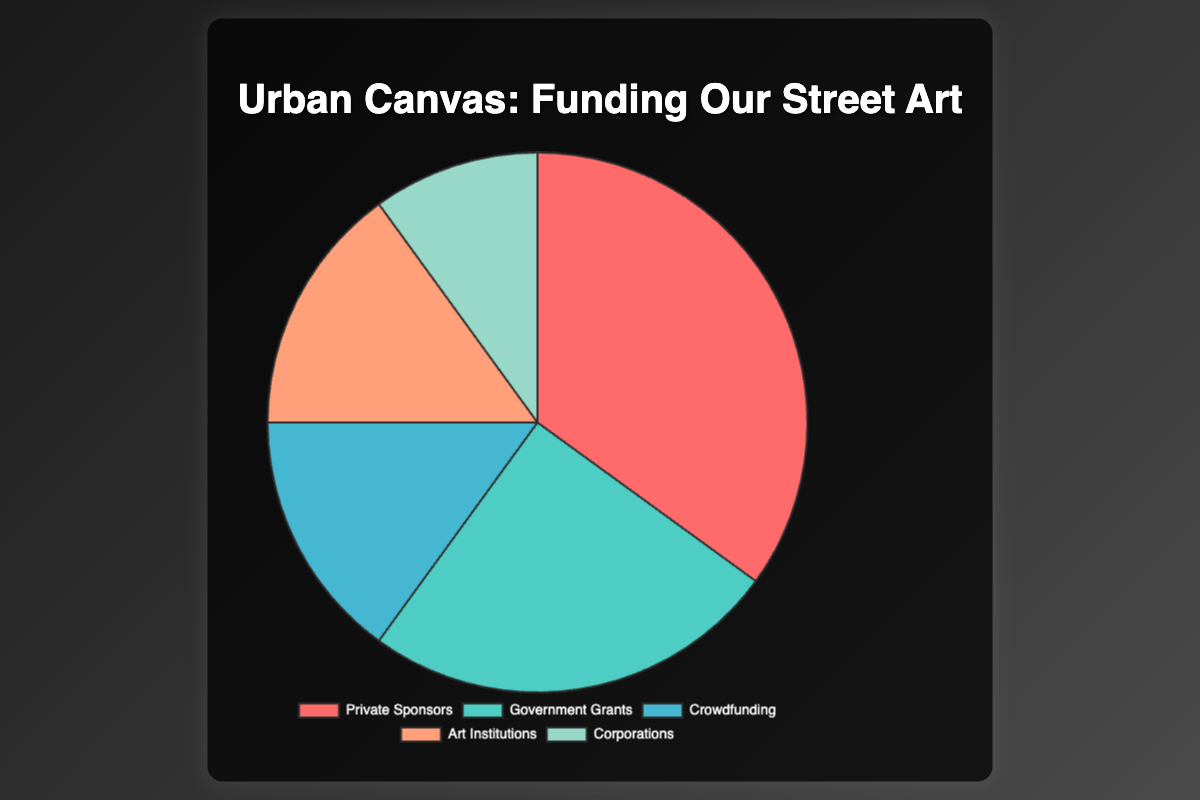What is the largest source of funding for street art projects? The figure shows the share of each funding source in the form of a pie chart. The segment with the highest percentage represents the largest source of funding. In this chart, Private Sponsors are the largest source, representing 35% of the total funding.
Answer: Private Sponsors Which funding sources contribute equally to street art projects? By examining the equal-sized segments of the pie chart, we can identify that Crowdfunding and Art Institutions each contribute 15% of the total funding.
Answer: Crowdfunding and Art Institutions What is the percentage difference between Government Grants and Corporations? From the pie chart, Government Grants cover 25% and Corporations cover 10% of the total funding. The percentage difference is calculated as 25% - 10% = 15%.
Answer: 15% How much more do Private Sponsors contribute compared to Crowdfunding? The chart shows Private Sponsors fund 35% while Crowdfunding provides 15%. The difference is 35% - 15% = 20%.
Answer: 20% What are the total contributions from non-private sources (Government Grants, Crowdfunding, Art Institutions, and Corporations)? Summing the percentages of Government Grants (25%), Crowdfunding (15%), Art Institutions (15%), and Corporations (10%) results in a total of 25% + 15% + 15% + 10% = 65%.
Answer: 65% Which category has the smallest contribution and what percentage does it constitute? The smallest segment in the pie chart corresponds to Corporations, which constitutes 10% of the total funding.
Answer: Corporations, 10% If we combine Art Institutions and Corporations, what proportion of the total funding would they represent? Adding the percentages of Art Institutions (15%) and Corporations (10%) gives a combined total of 15% + 10% = 25%.
Answer: 25% Which funding source is depicted with the color red? The color red in the pie chart represents the funding source with the highest percentage, which is Private Sponsors at 35%.
Answer: Private Sponsors 